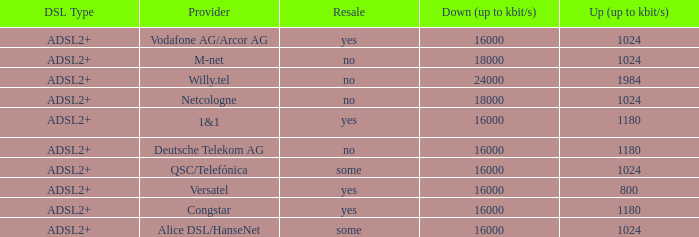Who are all of the telecom providers for which the upload rate is 1024 kbits and the resale category is yes? Vodafone AG/Arcor AG. 